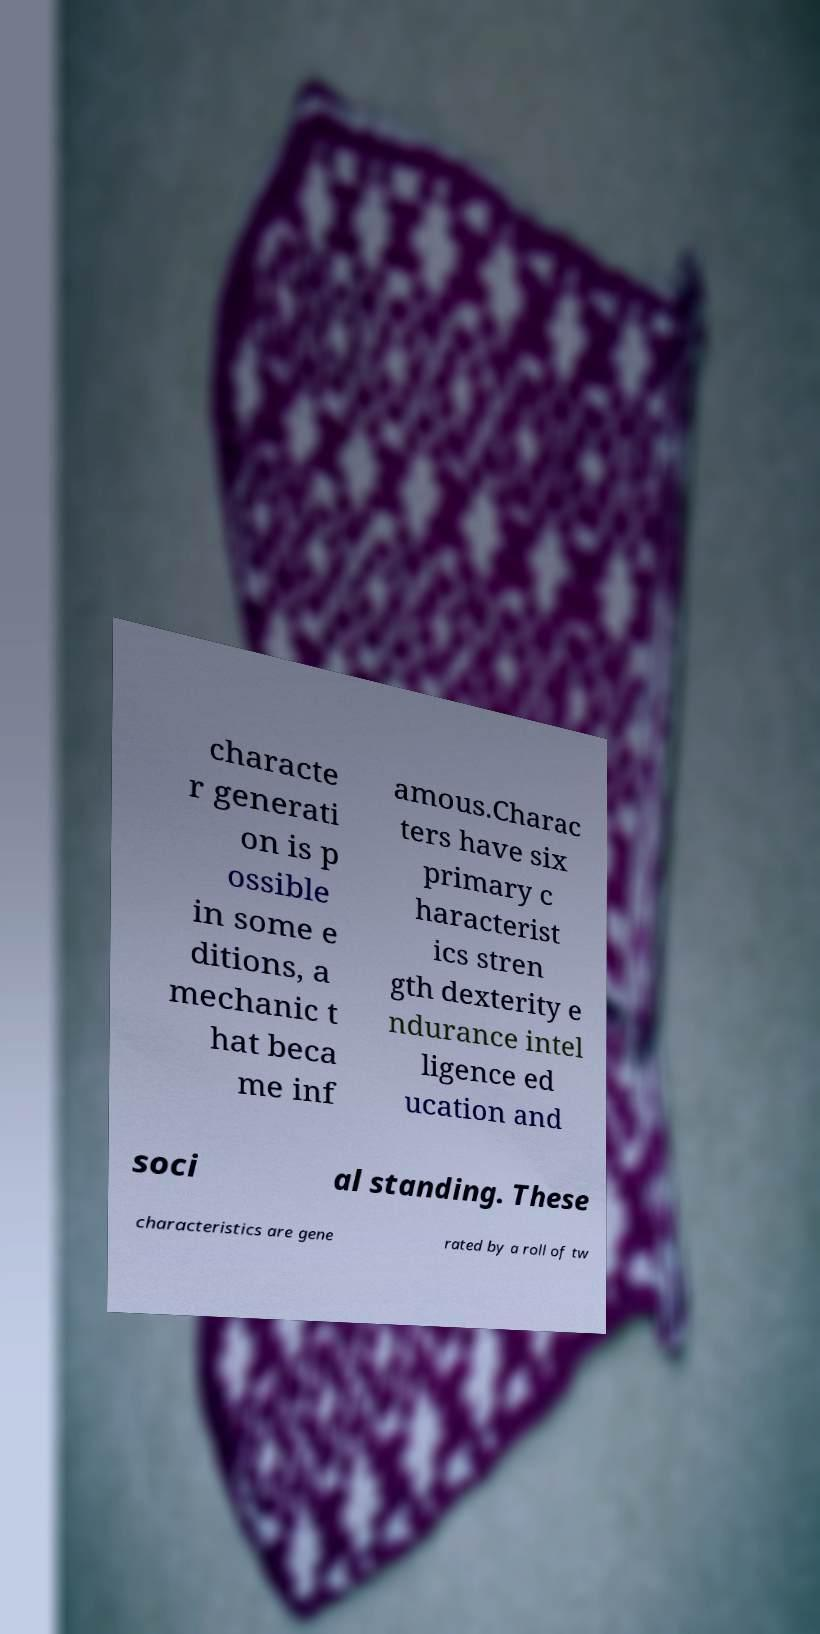Could you assist in decoding the text presented in this image and type it out clearly? characte r generati on is p ossible in some e ditions, a mechanic t hat beca me inf amous.Charac ters have six primary c haracterist ics stren gth dexterity e ndurance intel ligence ed ucation and soci al standing. These characteristics are gene rated by a roll of tw 